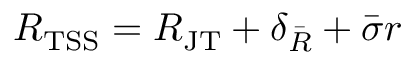Convert formula to latex. <formula><loc_0><loc_0><loc_500><loc_500>R _ { T S S } = R _ { J T } + \delta _ { \ B a r { R } } + \ B a r { \sigma } r</formula> 